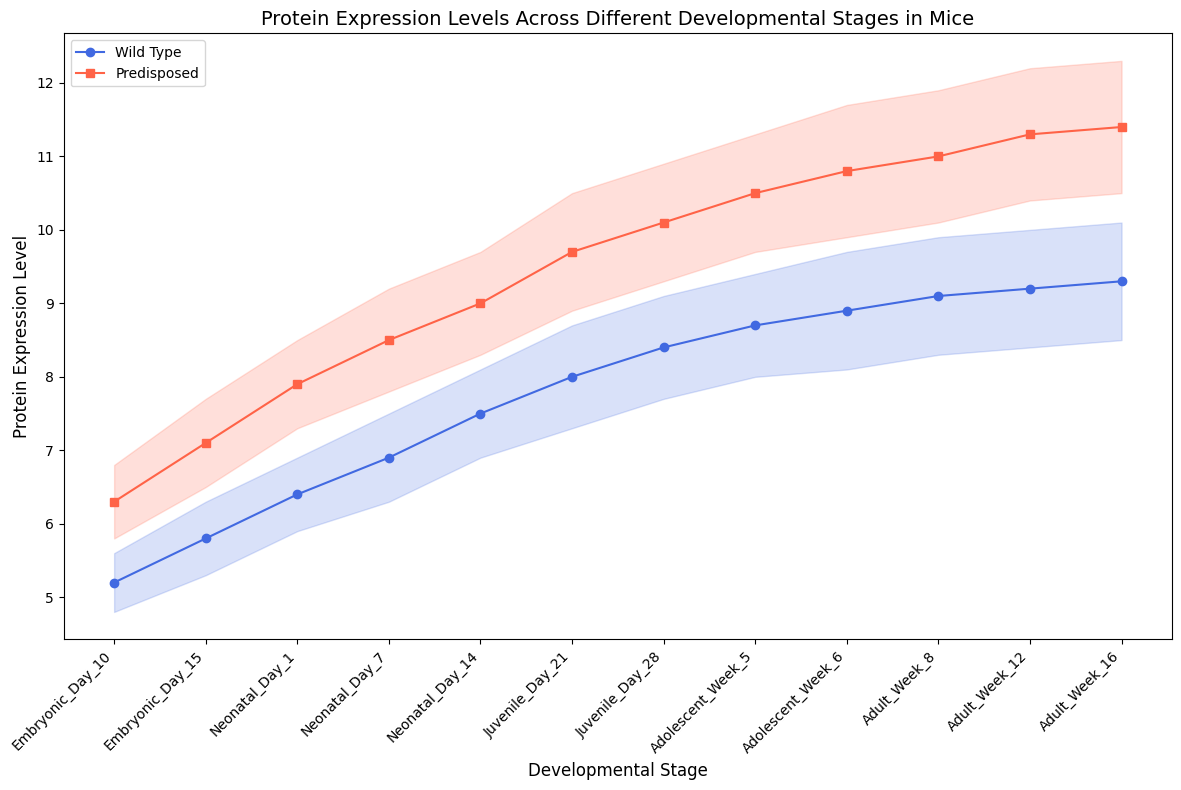What is the protein expression level of the wild type at Neonatal Day 7? The wild type protein expression level for each developmental stage is plotted in blue with markers. At Neonatal Day 7, trace the blue markers vertically to the y-axis to find the level.
Answer: 6.9 What is the difference in protein expression levels between wild type and predisposed mice at Embryonic Day 10? Compare the protein expression levels of wild type and predisposed mice at Embryonic Day 10. The wild type level is represented by the blue marker, while the predisposed level is represented by the red marker. Subtract the wild type value from the predisposed value: 6.3 - 5.2.
Answer: 1.1 How does the protein expression level in predisposed mice at Adult Week 16 compare to the wild type mice at the same stage? Compare the protein expression levels at Adult Week 16 for both wild type (blue marker) and predisposed mice (red marker). The values are 11.4 for predisposed and 9.3 for wild type. The predisposed level is higher.
Answer: Predisposed is higher At which developmental stage is the standard deviation for protein expression highest in wild type mice? Observe the shaded areas representing the standard deviation around the blue (wild type) line. The largest width indicates the highest standard deviation.
Answer: Adult Week 8 At which developmental stage does the protein expression level of wild type mice first exceed 8.0? Look at the blue line and trace where it first crosses the 8.0 mark on the y-axis.
Answer: Juvenile Day 21 What is the average protein expression level for predisposed mice during the Adolescent and Adult stages combined? Identify the protein expression values for predisposed mice during these stages (10.5, 10.8, 11.0, 11.3, 11.4) and calculate the average: (10.5 + 10.8 + 11.0 + 11.3 + 11.4) / 5
Answer: 11.0 By how much does the protein expression level in wild type mice increase from Neonatal Day 14 to Juvenile Day 28? Subtract protein expression level at Neonatal Day 14 from that at Juvenile Day 28: 8.4 - 7.5
Answer: 0.9 Compare the variability in protein expression levels between wild type and predisposed mice at Adolescent Week 5. Which has a higher variability? Variability is depicted by the shaded area around the lines. At Adolescent Week 5, compare the width of the shaded regions around the blue (wild type) and red (predisposed) lines. Red shaded region is wider.
Answer: Predisposed has higher variability 